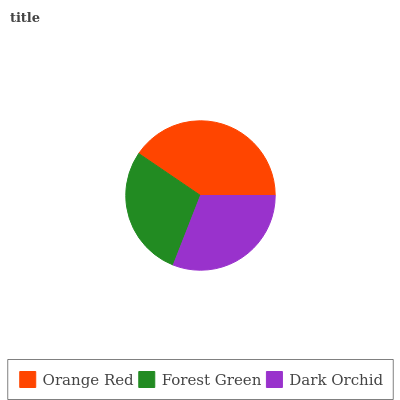Is Forest Green the minimum?
Answer yes or no. Yes. Is Orange Red the maximum?
Answer yes or no. Yes. Is Dark Orchid the minimum?
Answer yes or no. No. Is Dark Orchid the maximum?
Answer yes or no. No. Is Dark Orchid greater than Forest Green?
Answer yes or no. Yes. Is Forest Green less than Dark Orchid?
Answer yes or no. Yes. Is Forest Green greater than Dark Orchid?
Answer yes or no. No. Is Dark Orchid less than Forest Green?
Answer yes or no. No. Is Dark Orchid the high median?
Answer yes or no. Yes. Is Dark Orchid the low median?
Answer yes or no. Yes. Is Forest Green the high median?
Answer yes or no. No. Is Forest Green the low median?
Answer yes or no. No. 